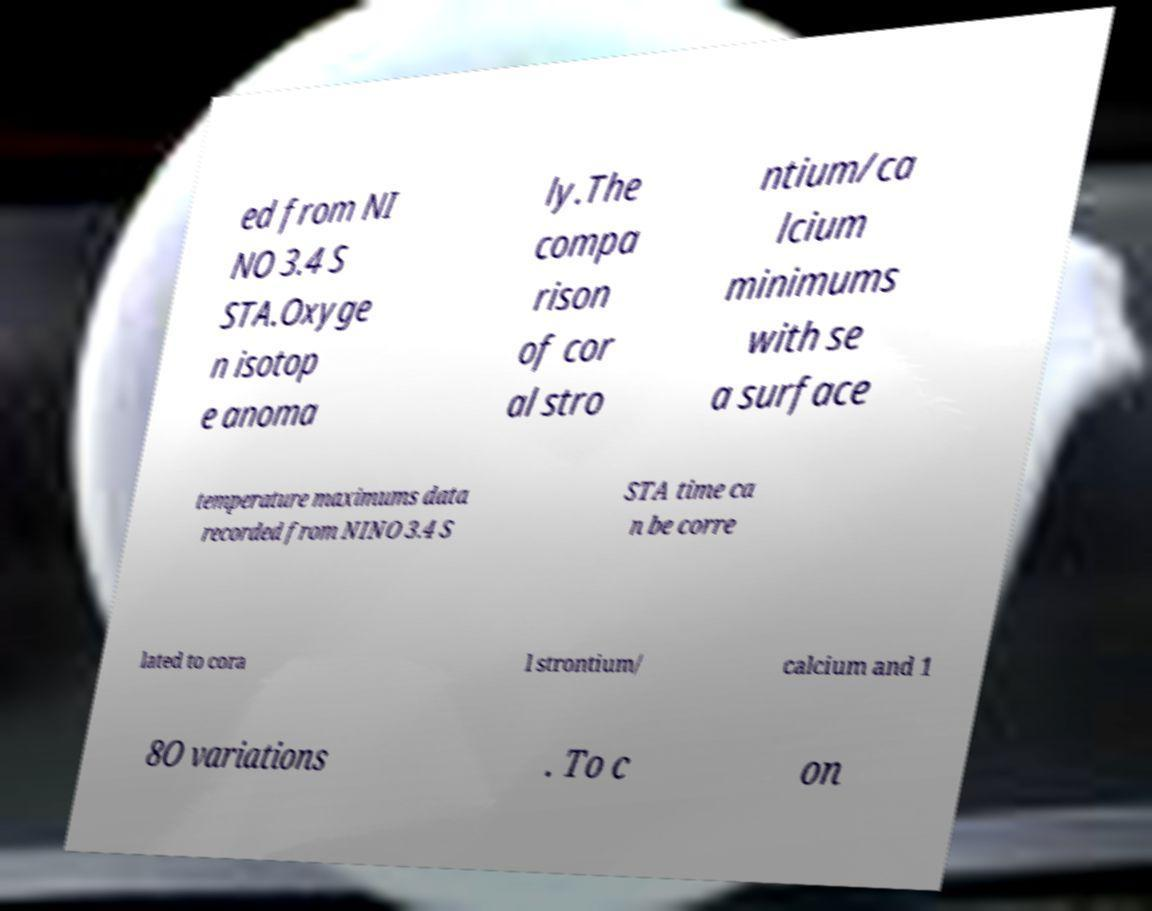For documentation purposes, I need the text within this image transcribed. Could you provide that? ed from NI NO 3.4 S STA.Oxyge n isotop e anoma ly.The compa rison of cor al stro ntium/ca lcium minimums with se a surface temperature maximums data recorded from NINO 3.4 S STA time ca n be corre lated to cora l strontium/ calcium and 1 8O variations . To c on 